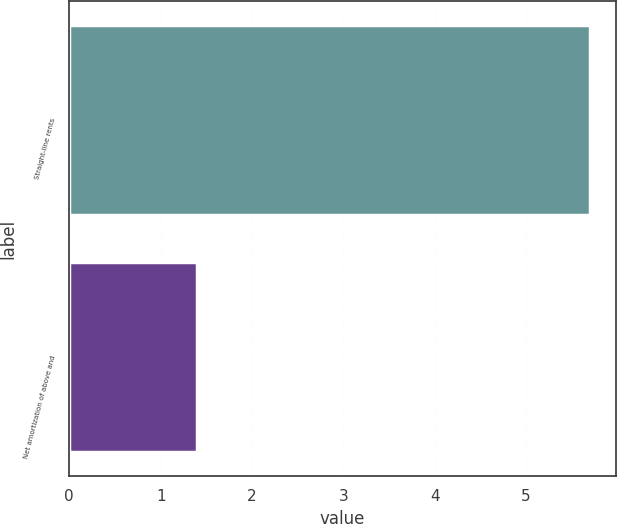Convert chart to OTSL. <chart><loc_0><loc_0><loc_500><loc_500><bar_chart><fcel>Straight-line rents<fcel>Net amortization of above and<nl><fcel>5.7<fcel>1.4<nl></chart> 